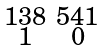Convert formula to latex. <formula><loc_0><loc_0><loc_500><loc_500>\begin{smallmatrix} 1 3 8 & 5 4 1 \\ 1 & 0 \end{smallmatrix}</formula> 